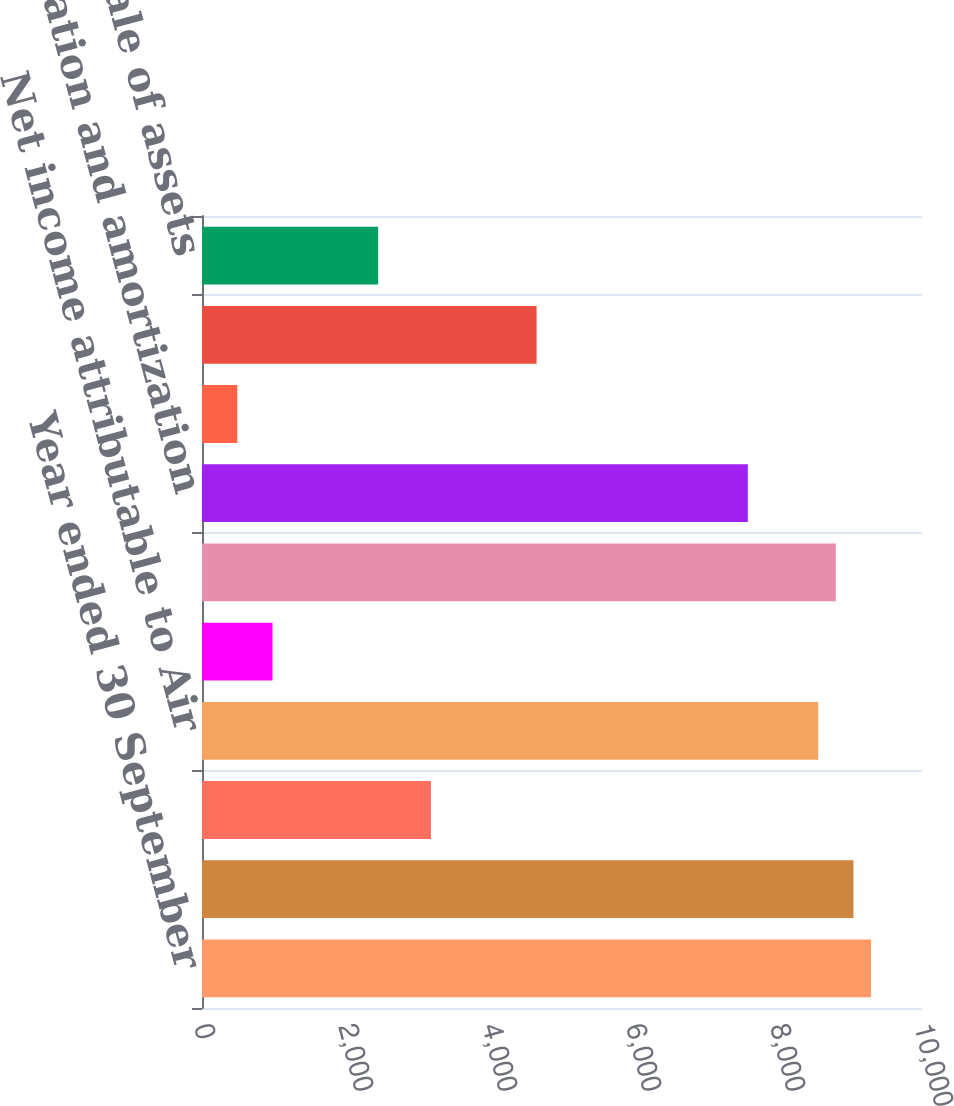Convert chart to OTSL. <chart><loc_0><loc_0><loc_500><loc_500><bar_chart><fcel>Year ended 30 September<fcel>Net Income<fcel>Less Net income attributable<fcel>Net income attributable to Air<fcel>Loss from discontinued<fcel>Income from continuing<fcel>Depreciation and amortization<fcel>Deferred income taxes<fcel>Undistributed earnings of<fcel>(Gain) Loss on sale of assets<nl><fcel>9292.4<fcel>9047.9<fcel>3179.9<fcel>8558.9<fcel>979.4<fcel>8803.4<fcel>7580.9<fcel>490.4<fcel>4646.9<fcel>2446.4<nl></chart> 